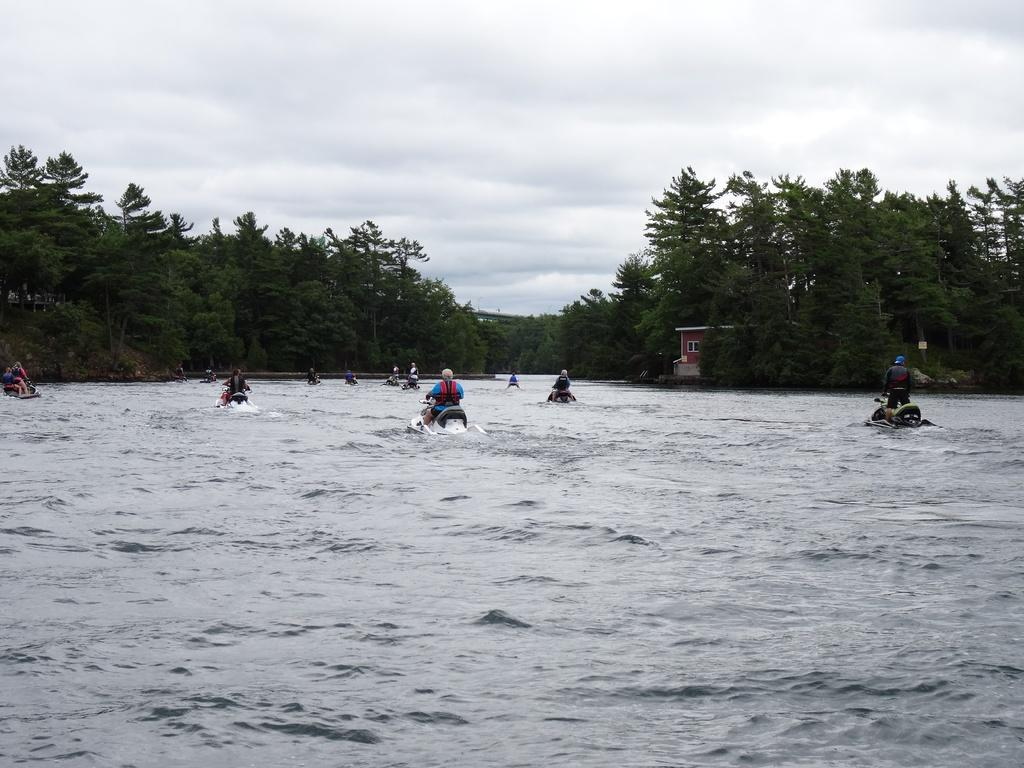What is the main element in the image? There is water in the image. What are the people in the image doing? People are riding a jet bike in the water. What protective gear are the people wearing? The people are wearing helmets and jackets. What can be seen in the background of the image? There are plants, trees, and the sky visible in the background of the image. Is there a beggar asking for money in the image? No, there is no beggar asking for money in the image. Can you see a notebook being used by the people in the image? No, there is no notebook visible in the image. 